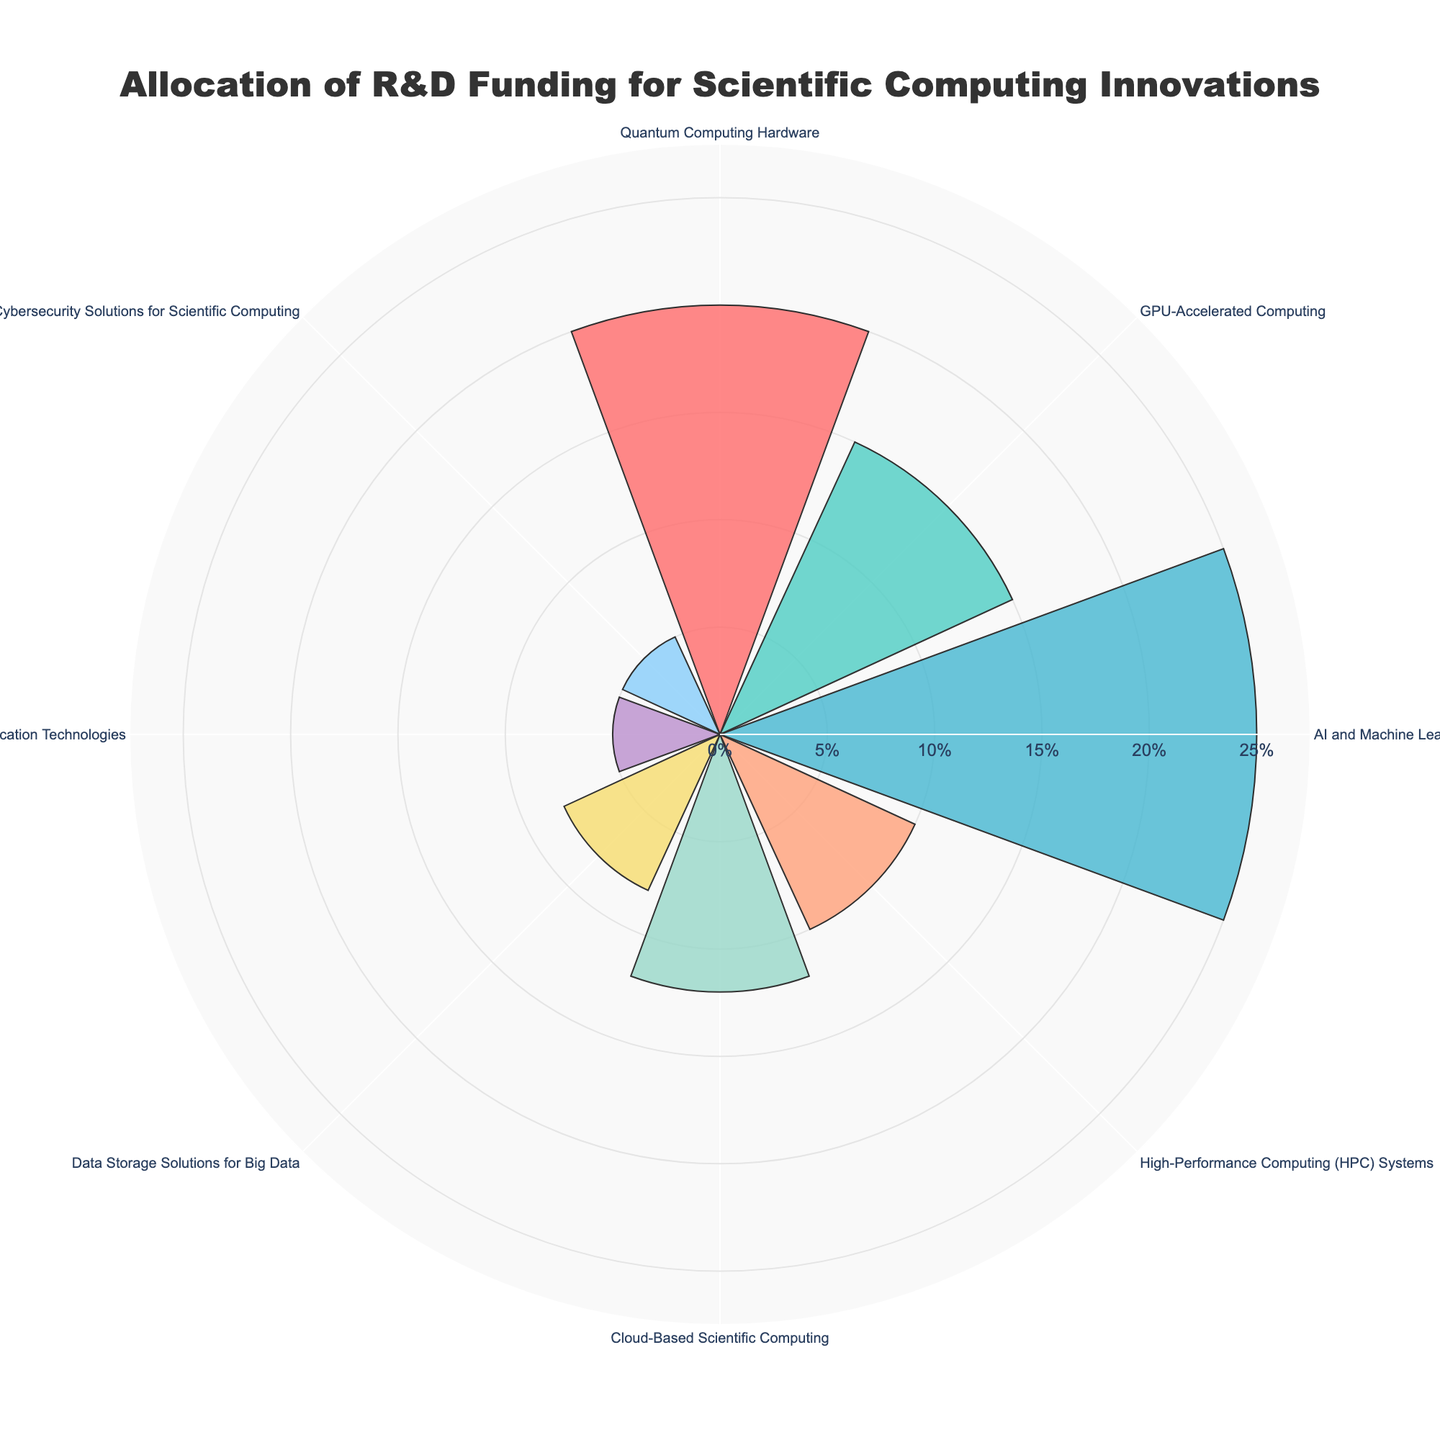what's the title of the plot? The title is usually located at the top of the chart and is often the largest text. In this case, it states, "Allocation of R&D Funding for Scientific Computing Innovations".
Answer: Allocation of R&D Funding for Scientific Computing Innovations which category has the highest proportion of R&D funding allocated? By looking at the length of the bars in the rose chart, the category with the longest bar represents the highest proportion. In this case, it is "AI and Machine Learning Frameworks".
Answer: AI and Machine Learning Frameworks what is the proportion of R&D funding allocated to Cloud-Based Scientific Computing? Each segment in the rose chart represents a different category and its corresponding proportion. The segment for "Cloud-Based Scientific Computing" shows a proportion of 0.12.
Answer: 0.12 how many categories have a proportion less than 0.10? To answer this, identify and count the segments where the value is less than 0.10. These are "Data Storage Solutions for Big Data," "Networking and Communication Technologies," and "Cybersecurity Solutions for Scientific Computing".
Answer: 3 compare the proportion of funding for GPU-Accelerated Computing with Cybersecurity Solutions. Which one has a higher proportion and by how much? The proportion for GPU-Accelerated Computing is 0.15, and for Cybersecurity Solutions, it is 0.05. The difference is 0.15 - 0.05 = 0.10, meaning GPU-Accelerated Computing has a higher proportion by 0.10.
Answer: GPU-Accelerated Computing by 0.10 what’s the combined proportion of funding allocated to Quantum Computing Hardware and High-Performance Computing (HPC) Systems? Adding the proportions of Quantum Computing Hardware (0.20) and HPC Systems (0.10) results in 0.20 + 0.10 = 0.30.
Answer: 0.30 what categories have an equal proportion of R&D funding, and what is the proportion? Looking at the data, "Networking and Communication Technologies" and "Cybersecurity Solutions for Scientific Computing" both have a proportion of 0.05.
Answer: Networking and Communication Technologies and Cybersecurity Solutions for Scientific Computing, 0.05 how is the radial axis in the rose chart labeled? The radial axis shows the range of proportions, with tick marks indicating specific percentage values. It is labeled from 0 to a bit above the highest proportion, with tick marks at regular intervals (in percentage).
Answer: Tick marks and percentage labels which categories have a proportional difference of 0.10 or more between them and another category? Categories with significant differences include "Quantum Computing Hardware" (0.20) vs. "Data Storage Solutions for Big Data" (0.08), "AI and Machine Learning Frameworks" (0.25) vs. "High-Performance Computing (HPC) Systems" (0.10), and several more. Inspecting visually or calculating differences can detect them.
Answer: Quantum Computing Hardware vs. Data Storage Solutions; AI and Machine Learning Frameworks vs. HPC Systems; more can be identified 